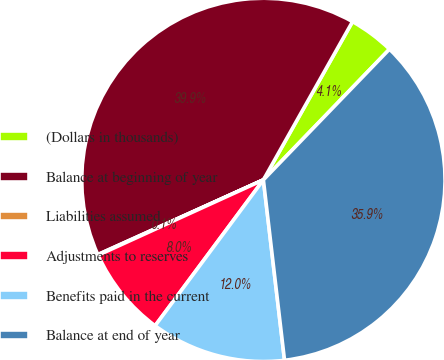Convert chart. <chart><loc_0><loc_0><loc_500><loc_500><pie_chart><fcel>(Dollars in thousands)<fcel>Balance at beginning of year<fcel>Liabilities assumed<fcel>Adjustments to reserves<fcel>Benefits paid in the current<fcel>Balance at end of year<nl><fcel>4.05%<fcel>39.91%<fcel>0.06%<fcel>8.03%<fcel>12.02%<fcel>35.93%<nl></chart> 